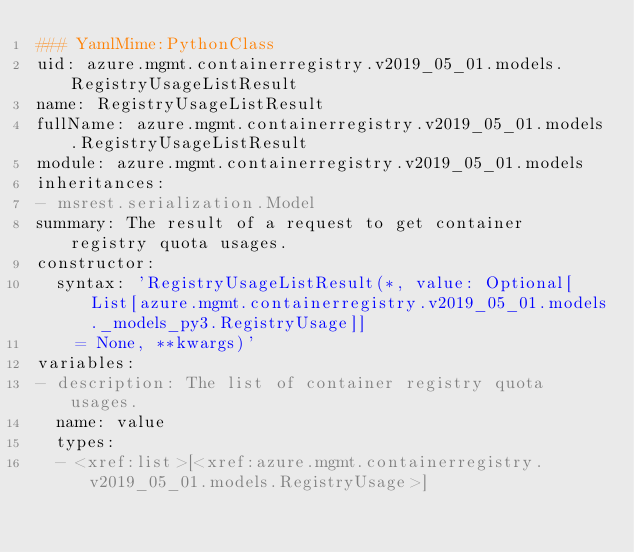<code> <loc_0><loc_0><loc_500><loc_500><_YAML_>### YamlMime:PythonClass
uid: azure.mgmt.containerregistry.v2019_05_01.models.RegistryUsageListResult
name: RegistryUsageListResult
fullName: azure.mgmt.containerregistry.v2019_05_01.models.RegistryUsageListResult
module: azure.mgmt.containerregistry.v2019_05_01.models
inheritances:
- msrest.serialization.Model
summary: The result of a request to get container registry quota usages.
constructor:
  syntax: 'RegistryUsageListResult(*, value: Optional[List[azure.mgmt.containerregistry.v2019_05_01.models._models_py3.RegistryUsage]]
    = None, **kwargs)'
variables:
- description: The list of container registry quota usages.
  name: value
  types:
  - <xref:list>[<xref:azure.mgmt.containerregistry.v2019_05_01.models.RegistryUsage>]
</code> 